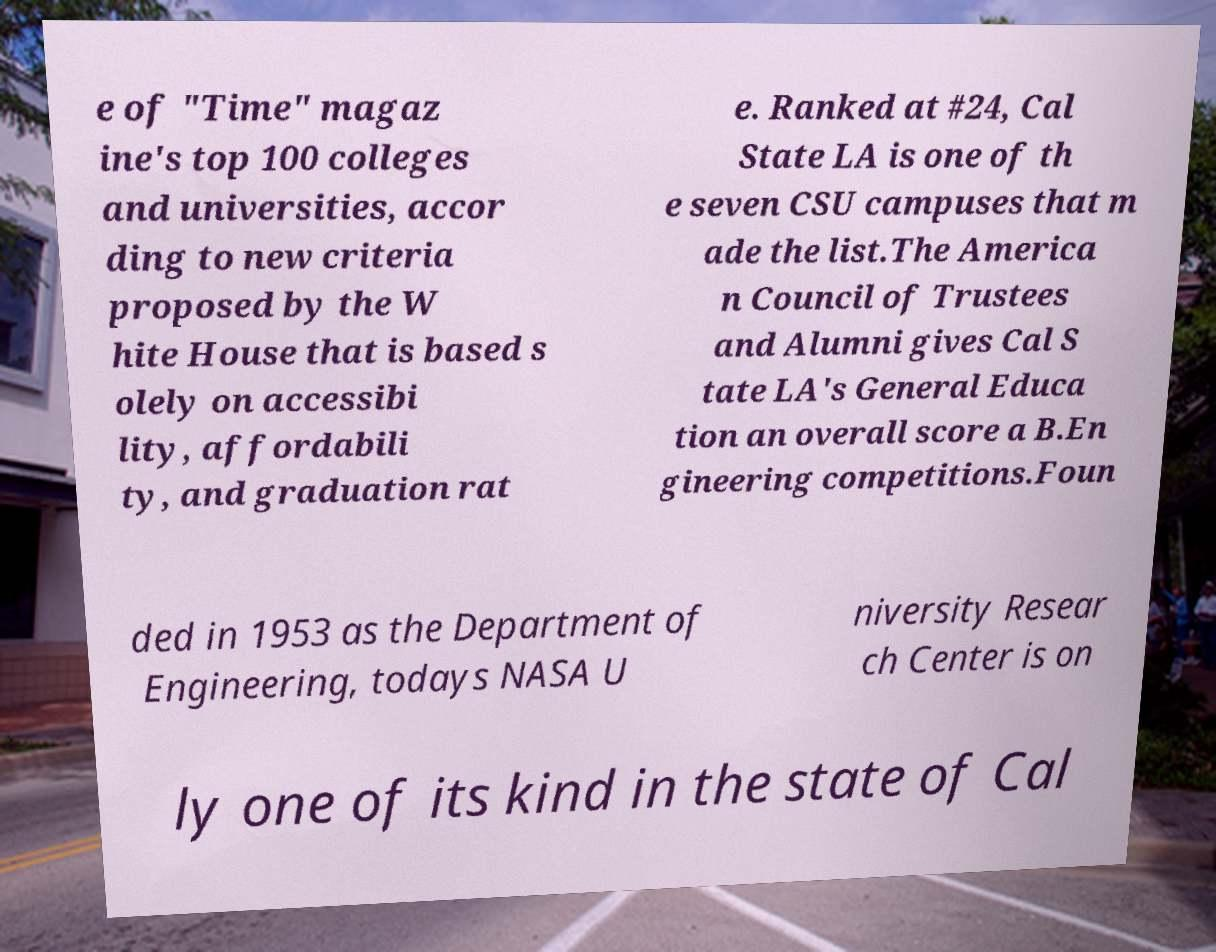Could you extract and type out the text from this image? e of "Time" magaz ine's top 100 colleges and universities, accor ding to new criteria proposed by the W hite House that is based s olely on accessibi lity, affordabili ty, and graduation rat e. Ranked at #24, Cal State LA is one of th e seven CSU campuses that m ade the list.The America n Council of Trustees and Alumni gives Cal S tate LA's General Educa tion an overall score a B.En gineering competitions.Foun ded in 1953 as the Department of Engineering, todays NASA U niversity Resear ch Center is on ly one of its kind in the state of Cal 